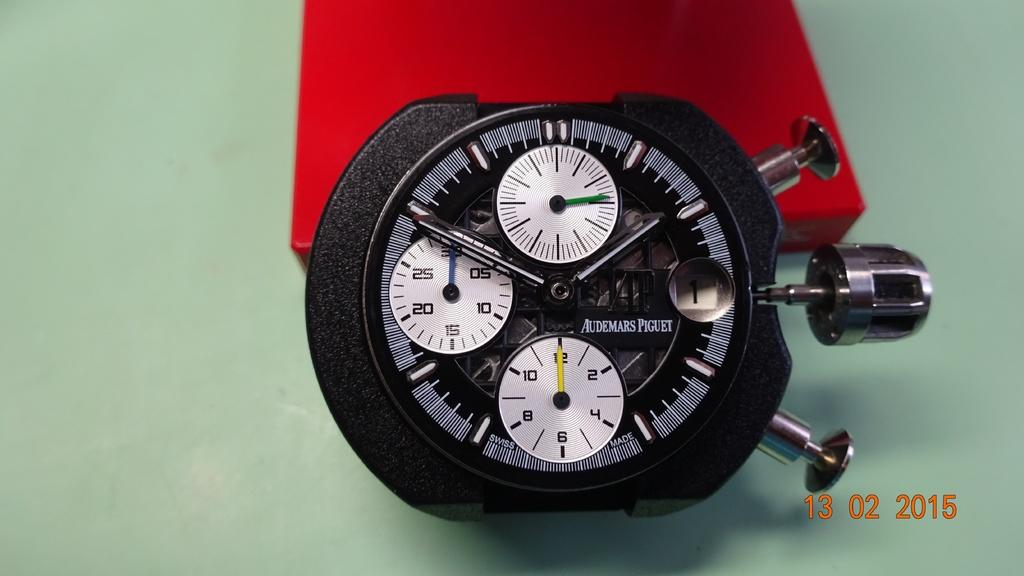Provide a one-sentence caption for the provided image. A black stopwatch leaning on a red box has several faces and smaller clocks within it and writing that reads Audemars Piguet on it. 